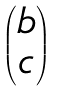Convert formula to latex. <formula><loc_0><loc_0><loc_500><loc_500>\begin{pmatrix} b \\ c \end{pmatrix}</formula> 